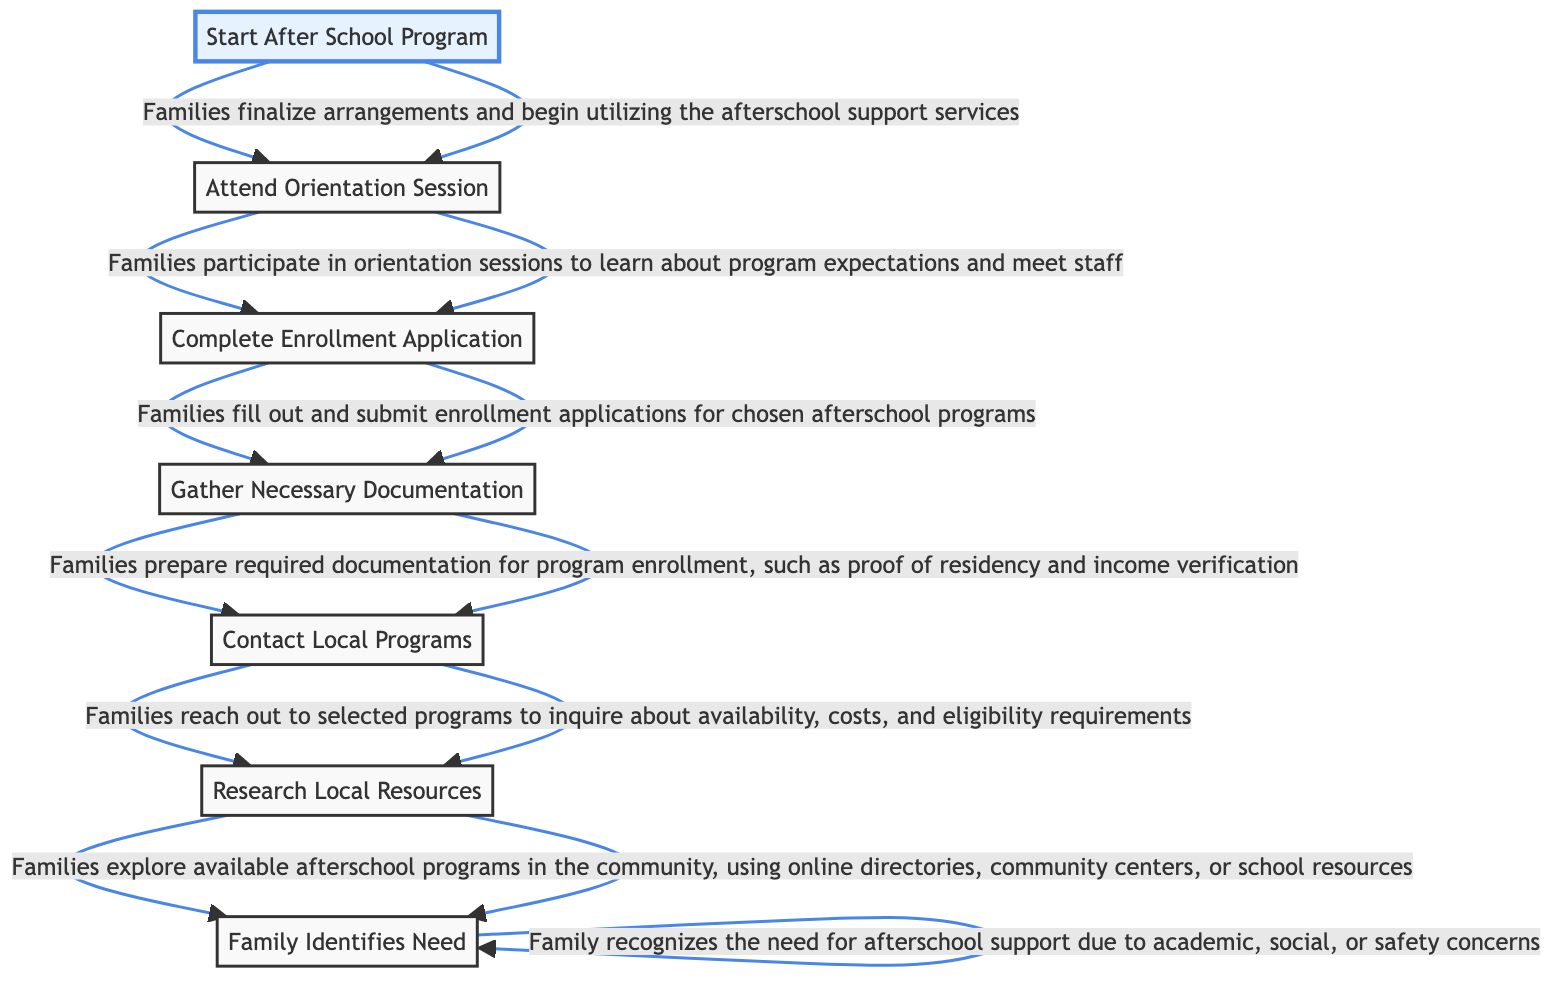What is the first step in the referral process? The first step in the process, as represented by the bottom node, is "Family Identifies Need." This node is the starting point that leads to subsequent actions within the diagram.
Answer: Family Identifies Need How many steps are there in the referral process? To determine the total number of steps, count each unique node displayed in the diagram. There are seven distinct steps listed.
Answer: 7 Which step precedes the "Complete Enrollment Application"? By tracing the flowchart upward, "Gather Necessary Documentation" is directly connected to "Complete Enrollment Application," indicating that it comes right before it in the sequence of steps.
Answer: Gather Necessary Documentation What do families do after attending the orientation session? Following the "Attend Orientation Session" step, the next action taken by families is to "Complete Enrollment Application." This shows the flow of activities that follow orientation.
Answer: Complete Enrollment Application What is the main goal of families in the first step? In the "Family Identifies Need" step, families aim to recognize their requirement for afterschool support, which is the primary objective of this initial stage.
Answer: afterschool support Explain the relationship between "Research Local Resources" and "Contact Local Programs". "Research Local Resources" leads directly to "Contact Local Programs." This sequence indicates that families need to first find out what programs are available before reaching out to them, highlighting a crucial dependency in the referral process.
Answer: Research leads to Contact What happens immediately after families finalize arrangements? Once families finalize their arrangements in the "Start After School Program" step, they begin utilizing the afterschool support services, which culminates the entire referral process.
Answer: Begin utilizing services What required documentation must families gather before enrollment? The step "Gather Necessary Documentation" specifies that families need to prepare items such as proof of residency and income verification, which are essential for enrolling in the program.
Answer: proof of residency and income verification Which step indicates families need to inquire about availability? The step "Contact Local Programs" indicates that families need to reach out to local programs to inquire about availability, costs, and eligibility requirements, marking a significant action in their exploration process.
Answer: Contact Local Programs 